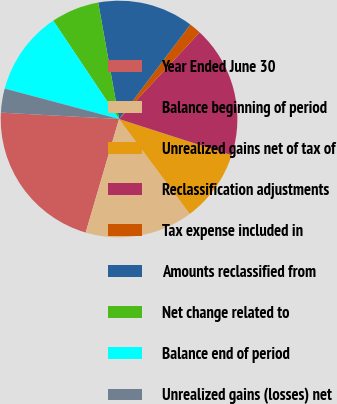Convert chart. <chart><loc_0><loc_0><loc_500><loc_500><pie_chart><fcel>Year Ended June 30<fcel>Balance beginning of period<fcel>Unrealized gains net of tax of<fcel>Reclassification adjustments<fcel>Tax expense included in<fcel>Amounts reclassified from<fcel>Net change related to<fcel>Balance end of period<fcel>Unrealized gains (losses) net<nl><fcel>21.31%<fcel>14.75%<fcel>9.84%<fcel>18.03%<fcel>1.64%<fcel>13.11%<fcel>6.56%<fcel>11.48%<fcel>3.28%<nl></chart> 